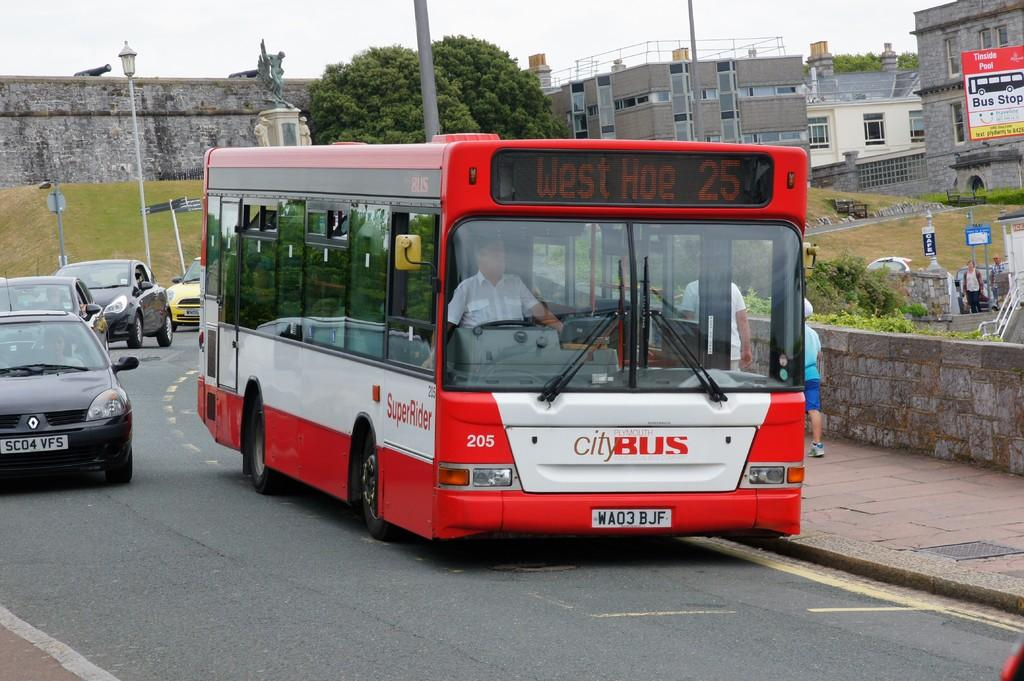<image>
Render a clear and concise summary of the photo. a red city bus that headlines west hoe 25 